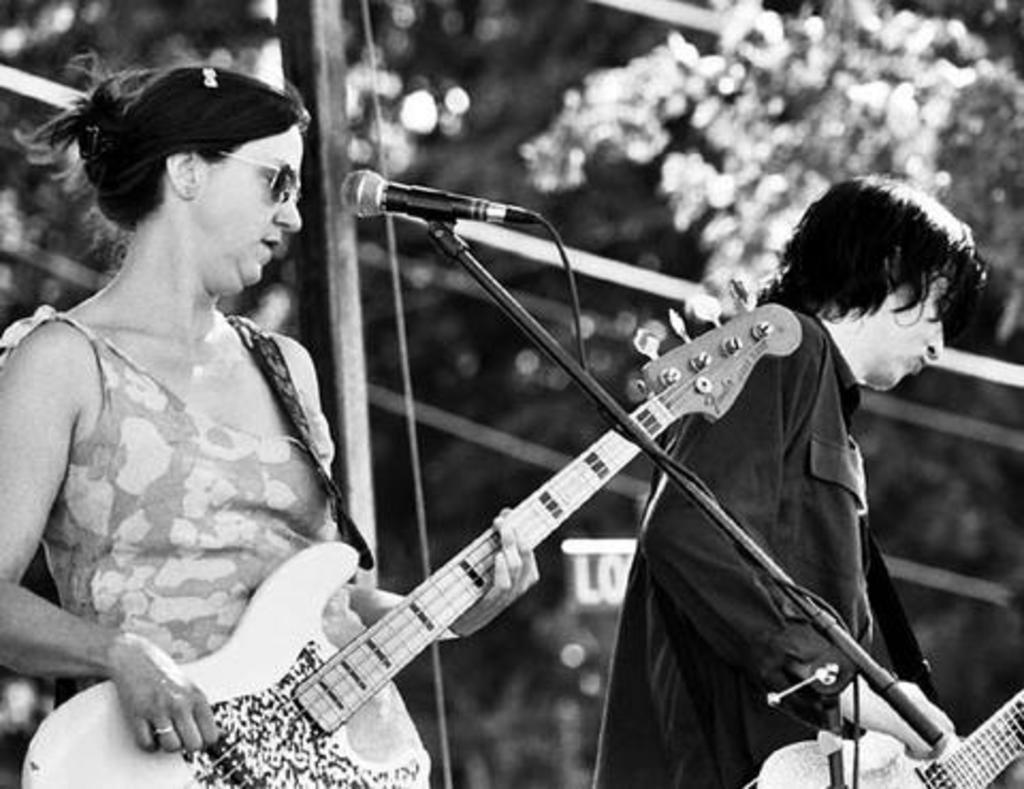Can you describe this image briefly? This is a black and white picture a lady to the left is holding a guitar in her hands and standing in front of a mic having a goggles, to the right a person dressed in black in color holding a guitar too. In the background i could see some trees. 